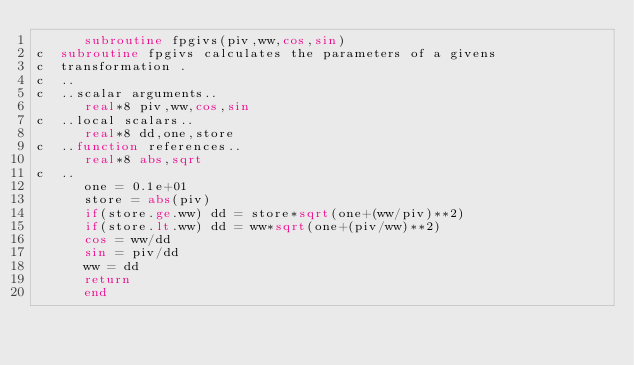<code> <loc_0><loc_0><loc_500><loc_500><_FORTRAN_>      subroutine fpgivs(piv,ww,cos,sin)
c  subroutine fpgivs calculates the parameters of a givens
c  transformation .
c  ..
c  ..scalar arguments..
      real*8 piv,ww,cos,sin
c  ..local scalars..
      real*8 dd,one,store
c  ..function references..
      real*8 abs,sqrt
c  ..
      one = 0.1e+01
      store = abs(piv)
      if(store.ge.ww) dd = store*sqrt(one+(ww/piv)**2)
      if(store.lt.ww) dd = ww*sqrt(one+(piv/ww)**2)
      cos = ww/dd
      sin = piv/dd
      ww = dd
      return
      end
</code> 